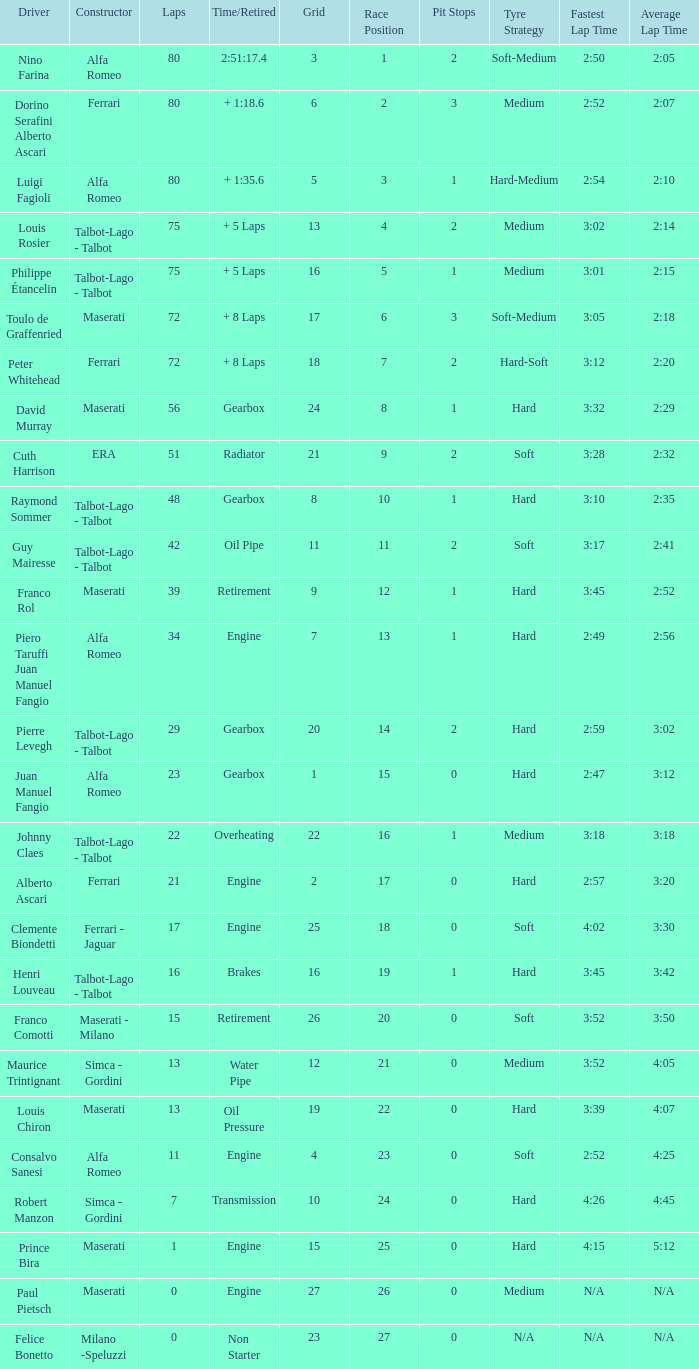When grid is less than 7, laps are greater than 17, and time/retired is + 1:35.6, who is the constructor? Alfa Romeo. 